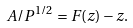Convert formula to latex. <formula><loc_0><loc_0><loc_500><loc_500>A / P ^ { 1 / 2 } = F ( z ) - z .</formula> 